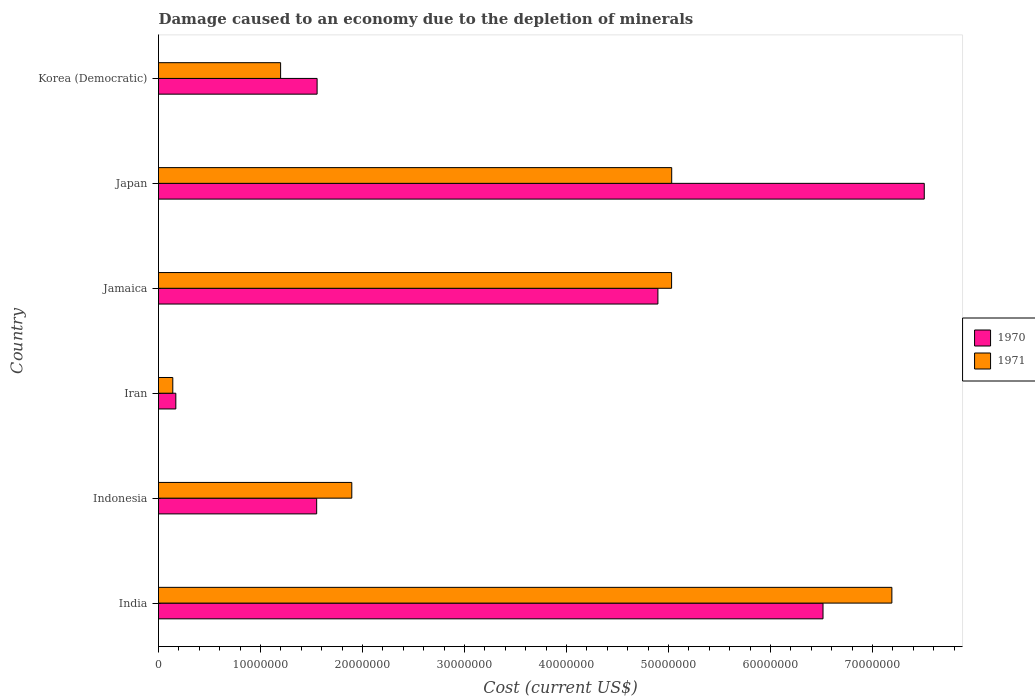How many different coloured bars are there?
Your answer should be very brief. 2. How many groups of bars are there?
Offer a terse response. 6. Are the number of bars on each tick of the Y-axis equal?
Your answer should be very brief. Yes. How many bars are there on the 6th tick from the top?
Your answer should be compact. 2. What is the label of the 5th group of bars from the top?
Offer a terse response. Indonesia. What is the cost of damage caused due to the depletion of minerals in 1971 in Japan?
Make the answer very short. 5.03e+07. Across all countries, what is the maximum cost of damage caused due to the depletion of minerals in 1970?
Ensure brevity in your answer.  7.51e+07. Across all countries, what is the minimum cost of damage caused due to the depletion of minerals in 1970?
Offer a terse response. 1.70e+06. In which country was the cost of damage caused due to the depletion of minerals in 1971 maximum?
Give a very brief answer. India. In which country was the cost of damage caused due to the depletion of minerals in 1970 minimum?
Keep it short and to the point. Iran. What is the total cost of damage caused due to the depletion of minerals in 1970 in the graph?
Make the answer very short. 2.22e+08. What is the difference between the cost of damage caused due to the depletion of minerals in 1970 in India and that in Japan?
Ensure brevity in your answer.  -9.93e+06. What is the difference between the cost of damage caused due to the depletion of minerals in 1971 in Indonesia and the cost of damage caused due to the depletion of minerals in 1970 in Jamaica?
Make the answer very short. -3.00e+07. What is the average cost of damage caused due to the depletion of minerals in 1970 per country?
Offer a terse response. 3.70e+07. What is the difference between the cost of damage caused due to the depletion of minerals in 1970 and cost of damage caused due to the depletion of minerals in 1971 in Iran?
Your answer should be very brief. 2.97e+05. What is the ratio of the cost of damage caused due to the depletion of minerals in 1971 in Jamaica to that in Korea (Democratic)?
Offer a terse response. 4.2. Is the difference between the cost of damage caused due to the depletion of minerals in 1970 in Japan and Korea (Democratic) greater than the difference between the cost of damage caused due to the depletion of minerals in 1971 in Japan and Korea (Democratic)?
Ensure brevity in your answer.  Yes. What is the difference between the highest and the second highest cost of damage caused due to the depletion of minerals in 1970?
Keep it short and to the point. 9.93e+06. What is the difference between the highest and the lowest cost of damage caused due to the depletion of minerals in 1970?
Your response must be concise. 7.34e+07. What does the 2nd bar from the bottom in India represents?
Offer a very short reply. 1971. How many bars are there?
Your answer should be very brief. 12. How many countries are there in the graph?
Provide a short and direct response. 6. What is the difference between two consecutive major ticks on the X-axis?
Provide a succinct answer. 1.00e+07. Does the graph contain grids?
Keep it short and to the point. No. Where does the legend appear in the graph?
Offer a very short reply. Center right. What is the title of the graph?
Keep it short and to the point. Damage caused to an economy due to the depletion of minerals. Does "1987" appear as one of the legend labels in the graph?
Provide a short and direct response. No. What is the label or title of the X-axis?
Keep it short and to the point. Cost (current US$). What is the label or title of the Y-axis?
Offer a terse response. Country. What is the Cost (current US$) of 1970 in India?
Give a very brief answer. 6.51e+07. What is the Cost (current US$) in 1971 in India?
Make the answer very short. 7.19e+07. What is the Cost (current US$) in 1970 in Indonesia?
Ensure brevity in your answer.  1.55e+07. What is the Cost (current US$) of 1971 in Indonesia?
Keep it short and to the point. 1.89e+07. What is the Cost (current US$) in 1970 in Iran?
Your response must be concise. 1.70e+06. What is the Cost (current US$) in 1971 in Iran?
Give a very brief answer. 1.40e+06. What is the Cost (current US$) in 1970 in Jamaica?
Make the answer very short. 4.90e+07. What is the Cost (current US$) in 1971 in Jamaica?
Your answer should be very brief. 5.03e+07. What is the Cost (current US$) in 1970 in Japan?
Your response must be concise. 7.51e+07. What is the Cost (current US$) in 1971 in Japan?
Your response must be concise. 5.03e+07. What is the Cost (current US$) of 1970 in Korea (Democratic)?
Your answer should be very brief. 1.55e+07. What is the Cost (current US$) in 1971 in Korea (Democratic)?
Offer a terse response. 1.20e+07. Across all countries, what is the maximum Cost (current US$) in 1970?
Offer a terse response. 7.51e+07. Across all countries, what is the maximum Cost (current US$) in 1971?
Provide a succinct answer. 7.19e+07. Across all countries, what is the minimum Cost (current US$) of 1970?
Provide a succinct answer. 1.70e+06. Across all countries, what is the minimum Cost (current US$) in 1971?
Offer a very short reply. 1.40e+06. What is the total Cost (current US$) of 1970 in the graph?
Your answer should be very brief. 2.22e+08. What is the total Cost (current US$) of 1971 in the graph?
Keep it short and to the point. 2.05e+08. What is the difference between the Cost (current US$) of 1970 in India and that in Indonesia?
Ensure brevity in your answer.  4.96e+07. What is the difference between the Cost (current US$) of 1971 in India and that in Indonesia?
Ensure brevity in your answer.  5.29e+07. What is the difference between the Cost (current US$) in 1970 in India and that in Iran?
Your response must be concise. 6.34e+07. What is the difference between the Cost (current US$) in 1971 in India and that in Iran?
Your response must be concise. 7.05e+07. What is the difference between the Cost (current US$) of 1970 in India and that in Jamaica?
Give a very brief answer. 1.62e+07. What is the difference between the Cost (current US$) of 1971 in India and that in Jamaica?
Keep it short and to the point. 2.16e+07. What is the difference between the Cost (current US$) of 1970 in India and that in Japan?
Ensure brevity in your answer.  -9.93e+06. What is the difference between the Cost (current US$) in 1971 in India and that in Japan?
Your answer should be very brief. 2.16e+07. What is the difference between the Cost (current US$) in 1970 in India and that in Korea (Democratic)?
Your answer should be very brief. 4.96e+07. What is the difference between the Cost (current US$) in 1971 in India and that in Korea (Democratic)?
Your answer should be very brief. 5.99e+07. What is the difference between the Cost (current US$) of 1970 in Indonesia and that in Iran?
Offer a very short reply. 1.38e+07. What is the difference between the Cost (current US$) in 1971 in Indonesia and that in Iran?
Your answer should be compact. 1.75e+07. What is the difference between the Cost (current US$) in 1970 in Indonesia and that in Jamaica?
Keep it short and to the point. -3.35e+07. What is the difference between the Cost (current US$) in 1971 in Indonesia and that in Jamaica?
Your response must be concise. -3.14e+07. What is the difference between the Cost (current US$) in 1970 in Indonesia and that in Japan?
Your answer should be compact. -5.96e+07. What is the difference between the Cost (current US$) in 1971 in Indonesia and that in Japan?
Keep it short and to the point. -3.14e+07. What is the difference between the Cost (current US$) in 1970 in Indonesia and that in Korea (Democratic)?
Provide a short and direct response. -4.23e+04. What is the difference between the Cost (current US$) of 1971 in Indonesia and that in Korea (Democratic)?
Give a very brief answer. 6.98e+06. What is the difference between the Cost (current US$) in 1970 in Iran and that in Jamaica?
Your answer should be very brief. -4.73e+07. What is the difference between the Cost (current US$) of 1971 in Iran and that in Jamaica?
Your answer should be compact. -4.89e+07. What is the difference between the Cost (current US$) of 1970 in Iran and that in Japan?
Offer a very short reply. -7.34e+07. What is the difference between the Cost (current US$) in 1971 in Iran and that in Japan?
Ensure brevity in your answer.  -4.89e+07. What is the difference between the Cost (current US$) in 1970 in Iran and that in Korea (Democratic)?
Your response must be concise. -1.38e+07. What is the difference between the Cost (current US$) in 1971 in Iran and that in Korea (Democratic)?
Your answer should be very brief. -1.06e+07. What is the difference between the Cost (current US$) of 1970 in Jamaica and that in Japan?
Make the answer very short. -2.61e+07. What is the difference between the Cost (current US$) in 1971 in Jamaica and that in Japan?
Offer a terse response. -1.04e+04. What is the difference between the Cost (current US$) in 1970 in Jamaica and that in Korea (Democratic)?
Provide a succinct answer. 3.34e+07. What is the difference between the Cost (current US$) of 1971 in Jamaica and that in Korea (Democratic)?
Offer a terse response. 3.83e+07. What is the difference between the Cost (current US$) of 1970 in Japan and that in Korea (Democratic)?
Offer a very short reply. 5.95e+07. What is the difference between the Cost (current US$) in 1971 in Japan and that in Korea (Democratic)?
Ensure brevity in your answer.  3.83e+07. What is the difference between the Cost (current US$) in 1970 in India and the Cost (current US$) in 1971 in Indonesia?
Offer a very short reply. 4.62e+07. What is the difference between the Cost (current US$) in 1970 in India and the Cost (current US$) in 1971 in Iran?
Provide a succinct answer. 6.37e+07. What is the difference between the Cost (current US$) of 1970 in India and the Cost (current US$) of 1971 in Jamaica?
Your response must be concise. 1.48e+07. What is the difference between the Cost (current US$) of 1970 in India and the Cost (current US$) of 1971 in Japan?
Make the answer very short. 1.48e+07. What is the difference between the Cost (current US$) of 1970 in India and the Cost (current US$) of 1971 in Korea (Democratic)?
Provide a short and direct response. 5.32e+07. What is the difference between the Cost (current US$) in 1970 in Indonesia and the Cost (current US$) in 1971 in Iran?
Your response must be concise. 1.41e+07. What is the difference between the Cost (current US$) of 1970 in Indonesia and the Cost (current US$) of 1971 in Jamaica?
Your answer should be compact. -3.48e+07. What is the difference between the Cost (current US$) of 1970 in Indonesia and the Cost (current US$) of 1971 in Japan?
Give a very brief answer. -3.48e+07. What is the difference between the Cost (current US$) in 1970 in Indonesia and the Cost (current US$) in 1971 in Korea (Democratic)?
Make the answer very short. 3.54e+06. What is the difference between the Cost (current US$) of 1970 in Iran and the Cost (current US$) of 1971 in Jamaica?
Provide a short and direct response. -4.86e+07. What is the difference between the Cost (current US$) in 1970 in Iran and the Cost (current US$) in 1971 in Japan?
Provide a short and direct response. -4.86e+07. What is the difference between the Cost (current US$) in 1970 in Iran and the Cost (current US$) in 1971 in Korea (Democratic)?
Give a very brief answer. -1.03e+07. What is the difference between the Cost (current US$) in 1970 in Jamaica and the Cost (current US$) in 1971 in Japan?
Provide a short and direct response. -1.35e+06. What is the difference between the Cost (current US$) of 1970 in Jamaica and the Cost (current US$) of 1971 in Korea (Democratic)?
Your response must be concise. 3.70e+07. What is the difference between the Cost (current US$) in 1970 in Japan and the Cost (current US$) in 1971 in Korea (Democratic)?
Provide a short and direct response. 6.31e+07. What is the average Cost (current US$) of 1970 per country?
Your answer should be very brief. 3.70e+07. What is the average Cost (current US$) in 1971 per country?
Ensure brevity in your answer.  3.41e+07. What is the difference between the Cost (current US$) of 1970 and Cost (current US$) of 1971 in India?
Make the answer very short. -6.75e+06. What is the difference between the Cost (current US$) in 1970 and Cost (current US$) in 1971 in Indonesia?
Your answer should be compact. -3.44e+06. What is the difference between the Cost (current US$) of 1970 and Cost (current US$) of 1971 in Iran?
Offer a very short reply. 2.97e+05. What is the difference between the Cost (current US$) in 1970 and Cost (current US$) in 1971 in Jamaica?
Ensure brevity in your answer.  -1.34e+06. What is the difference between the Cost (current US$) in 1970 and Cost (current US$) in 1971 in Japan?
Offer a terse response. 2.48e+07. What is the difference between the Cost (current US$) of 1970 and Cost (current US$) of 1971 in Korea (Democratic)?
Make the answer very short. 3.58e+06. What is the ratio of the Cost (current US$) of 1970 in India to that in Indonesia?
Keep it short and to the point. 4.2. What is the ratio of the Cost (current US$) in 1971 in India to that in Indonesia?
Offer a terse response. 3.79. What is the ratio of the Cost (current US$) of 1970 in India to that in Iran?
Your answer should be very brief. 38.38. What is the ratio of the Cost (current US$) in 1971 in India to that in Iran?
Provide a succinct answer. 51.36. What is the ratio of the Cost (current US$) of 1970 in India to that in Jamaica?
Ensure brevity in your answer.  1.33. What is the ratio of the Cost (current US$) in 1971 in India to that in Jamaica?
Make the answer very short. 1.43. What is the ratio of the Cost (current US$) in 1970 in India to that in Japan?
Your answer should be compact. 0.87. What is the ratio of the Cost (current US$) in 1971 in India to that in Japan?
Your response must be concise. 1.43. What is the ratio of the Cost (current US$) in 1970 in India to that in Korea (Democratic)?
Your answer should be compact. 4.19. What is the ratio of the Cost (current US$) of 1971 in India to that in Korea (Democratic)?
Keep it short and to the point. 6.01. What is the ratio of the Cost (current US$) in 1970 in Indonesia to that in Iran?
Offer a terse response. 9.14. What is the ratio of the Cost (current US$) of 1971 in Indonesia to that in Iran?
Ensure brevity in your answer.  13.54. What is the ratio of the Cost (current US$) in 1970 in Indonesia to that in Jamaica?
Your answer should be very brief. 0.32. What is the ratio of the Cost (current US$) in 1971 in Indonesia to that in Jamaica?
Give a very brief answer. 0.38. What is the ratio of the Cost (current US$) of 1970 in Indonesia to that in Japan?
Your answer should be very brief. 0.21. What is the ratio of the Cost (current US$) of 1971 in Indonesia to that in Japan?
Ensure brevity in your answer.  0.38. What is the ratio of the Cost (current US$) of 1971 in Indonesia to that in Korea (Democratic)?
Your answer should be compact. 1.58. What is the ratio of the Cost (current US$) in 1970 in Iran to that in Jamaica?
Provide a short and direct response. 0.03. What is the ratio of the Cost (current US$) in 1971 in Iran to that in Jamaica?
Keep it short and to the point. 0.03. What is the ratio of the Cost (current US$) in 1970 in Iran to that in Japan?
Ensure brevity in your answer.  0.02. What is the ratio of the Cost (current US$) in 1971 in Iran to that in Japan?
Offer a terse response. 0.03. What is the ratio of the Cost (current US$) in 1970 in Iran to that in Korea (Democratic)?
Offer a terse response. 0.11. What is the ratio of the Cost (current US$) in 1971 in Iran to that in Korea (Democratic)?
Offer a terse response. 0.12. What is the ratio of the Cost (current US$) of 1970 in Jamaica to that in Japan?
Offer a terse response. 0.65. What is the ratio of the Cost (current US$) of 1971 in Jamaica to that in Japan?
Your answer should be very brief. 1. What is the ratio of the Cost (current US$) in 1970 in Jamaica to that in Korea (Democratic)?
Offer a terse response. 3.15. What is the ratio of the Cost (current US$) in 1971 in Jamaica to that in Korea (Democratic)?
Your response must be concise. 4.2. What is the ratio of the Cost (current US$) in 1970 in Japan to that in Korea (Democratic)?
Make the answer very short. 4.83. What is the ratio of the Cost (current US$) of 1971 in Japan to that in Korea (Democratic)?
Your response must be concise. 4.2. What is the difference between the highest and the second highest Cost (current US$) in 1970?
Ensure brevity in your answer.  9.93e+06. What is the difference between the highest and the second highest Cost (current US$) in 1971?
Ensure brevity in your answer.  2.16e+07. What is the difference between the highest and the lowest Cost (current US$) in 1970?
Keep it short and to the point. 7.34e+07. What is the difference between the highest and the lowest Cost (current US$) of 1971?
Your response must be concise. 7.05e+07. 